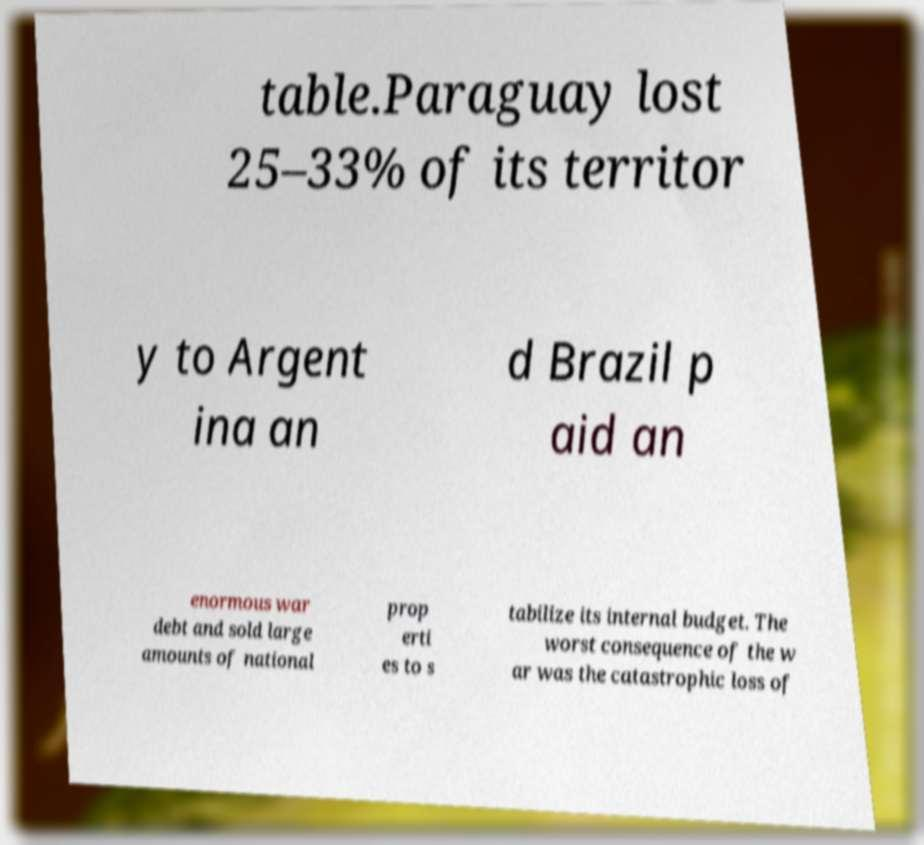Could you extract and type out the text from this image? table.Paraguay lost 25–33% of its territor y to Argent ina an d Brazil p aid an enormous war debt and sold large amounts of national prop erti es to s tabilize its internal budget. The worst consequence of the w ar was the catastrophic loss of 